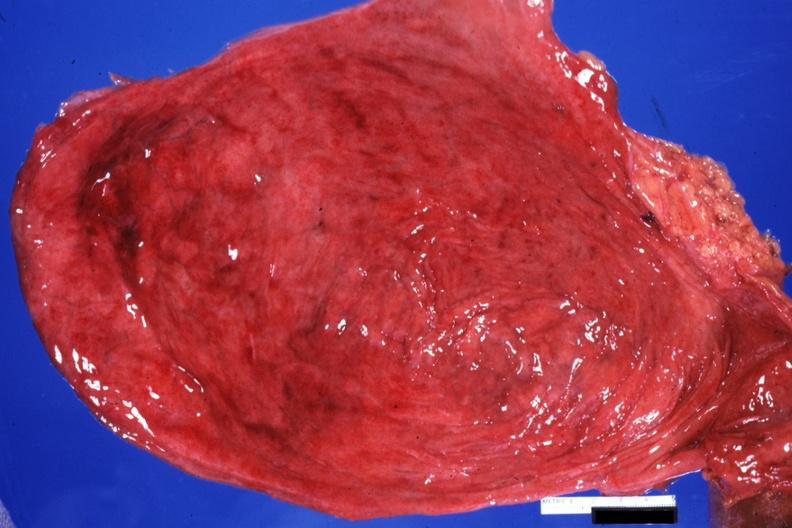what is present?
Answer the question using a single word or phrase. Bladder 